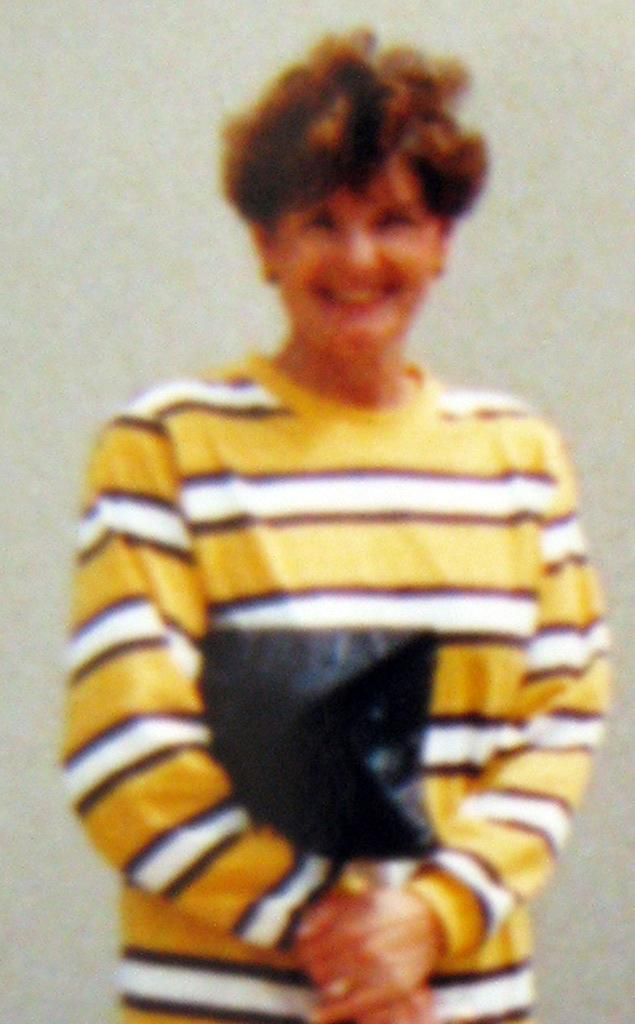What is present in the image? There is a person in the image. How is the person's expression in the image? The person is smiling. What type of orange is being picked by the laborer in the image? There is no laborer or orange present in the image; it only features a person who is smiling. 